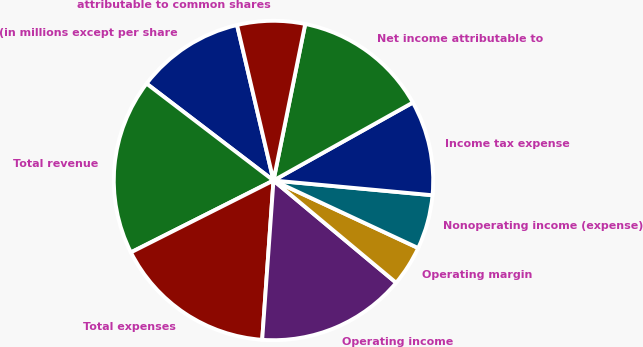<chart> <loc_0><loc_0><loc_500><loc_500><pie_chart><fcel>(in millions except per share<fcel>Total revenue<fcel>Total expenses<fcel>Operating income<fcel>Operating margin<fcel>Nonoperating income (expense)<fcel>Income tax expense<fcel>Net income attributable to<fcel>attributable to common shares<nl><fcel>10.96%<fcel>17.81%<fcel>16.44%<fcel>15.07%<fcel>4.11%<fcel>5.48%<fcel>9.59%<fcel>13.7%<fcel>6.85%<nl></chart> 